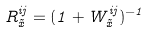Convert formula to latex. <formula><loc_0><loc_0><loc_500><loc_500>R ^ { i j } _ { \vec { x } } = ( 1 + W ^ { i j } _ { \vec { x } } ) ^ { - 1 }</formula> 